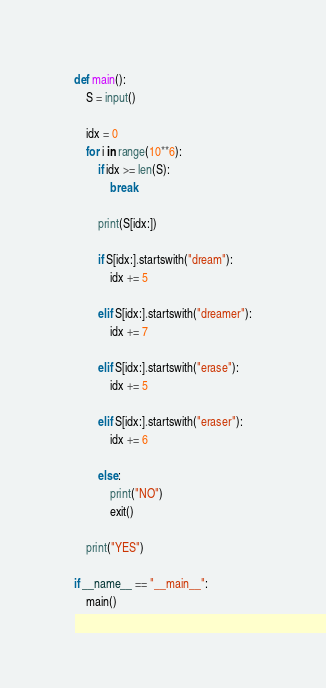Convert code to text. <code><loc_0><loc_0><loc_500><loc_500><_Python_>def main():
    S = input()

    idx = 0
    for i in range(10**6):
        if idx >= len(S):
            break

        print(S[idx:])

        if S[idx:].startswith("dream"):
            idx += 5

        elif S[idx:].startswith("dreamer"):
            idx += 7
        
        elif S[idx:].startswith("erase"):
            idx += 5

        elif S[idx:].startswith("eraser"):
            idx += 6

        else:
            print("NO")
            exit()

    print("YES")

if __name__ == "__main__":
    main()</code> 